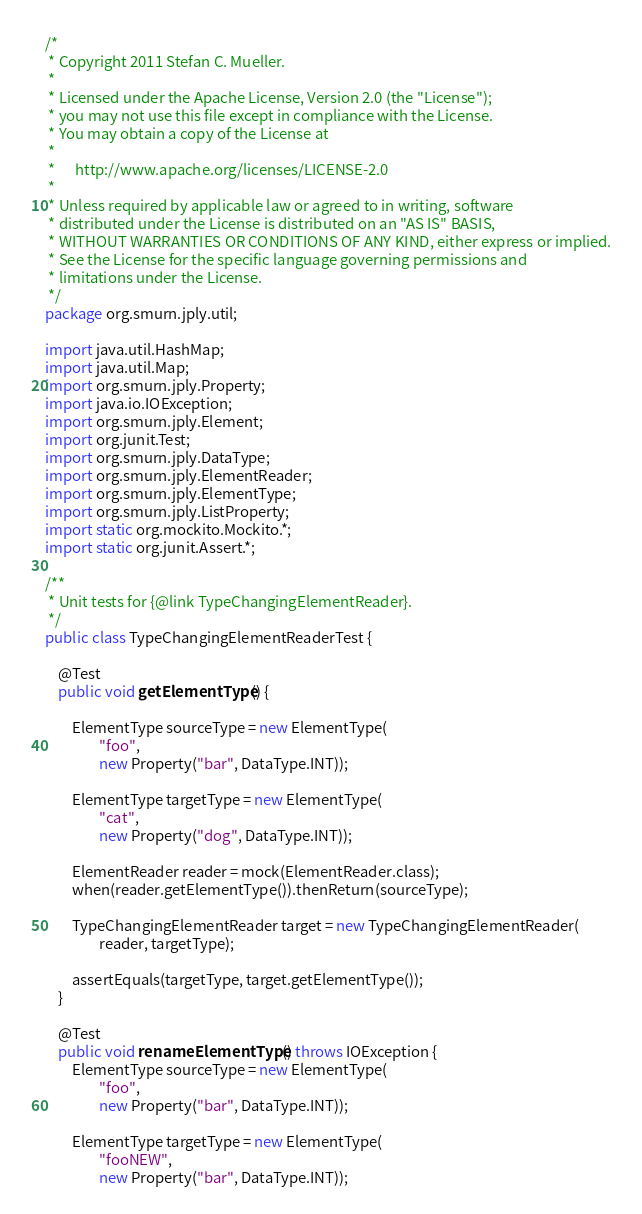<code> <loc_0><loc_0><loc_500><loc_500><_Java_>/*
 * Copyright 2011 Stefan C. Mueller.
 *
 * Licensed under the Apache License, Version 2.0 (the "License");
 * you may not use this file except in compliance with the License.
 * You may obtain a copy of the License at
 *
 *      http://www.apache.org/licenses/LICENSE-2.0
 *
 * Unless required by applicable law or agreed to in writing, software
 * distributed under the License is distributed on an "AS IS" BASIS,
 * WITHOUT WARRANTIES OR CONDITIONS OF ANY KIND, either express or implied.
 * See the License for the specific language governing permissions and
 * limitations under the License.
 */
package org.smurn.jply.util;

import java.util.HashMap;
import java.util.Map;
import org.smurn.jply.Property;
import java.io.IOException;
import org.smurn.jply.Element;
import org.junit.Test;
import org.smurn.jply.DataType;
import org.smurn.jply.ElementReader;
import org.smurn.jply.ElementType;
import org.smurn.jply.ListProperty;
import static org.mockito.Mockito.*;
import static org.junit.Assert.*;

/**
 * Unit tests for {@link TypeChangingElementReader}.
 */
public class TypeChangingElementReaderTest {

    @Test
    public void getElementType() {

        ElementType sourceType = new ElementType(
                "foo",
                new Property("bar", DataType.INT));

        ElementType targetType = new ElementType(
                "cat",
                new Property("dog", DataType.INT));

        ElementReader reader = mock(ElementReader.class);
        when(reader.getElementType()).thenReturn(sourceType);

        TypeChangingElementReader target = new TypeChangingElementReader(
                reader, targetType);

        assertEquals(targetType, target.getElementType());
    }

    @Test
    public void renameElementType() throws IOException {
        ElementType sourceType = new ElementType(
                "foo",
                new Property("bar", DataType.INT));

        ElementType targetType = new ElementType(
                "fooNEW",
                new Property("bar", DataType.INT));
</code> 